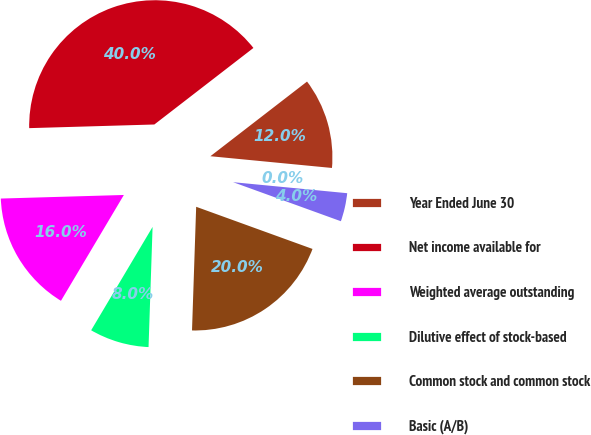<chart> <loc_0><loc_0><loc_500><loc_500><pie_chart><fcel>Year Ended June 30<fcel>Net income available for<fcel>Weighted average outstanding<fcel>Dilutive effect of stock-based<fcel>Common stock and common stock<fcel>Basic (A/B)<fcel>Diluted (A/C)<nl><fcel>12.0%<fcel>39.99%<fcel>16.0%<fcel>8.0%<fcel>20.0%<fcel>4.0%<fcel>0.0%<nl></chart> 